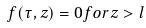<formula> <loc_0><loc_0><loc_500><loc_500>f ( \tau , z ) = 0 f o r z > l</formula> 